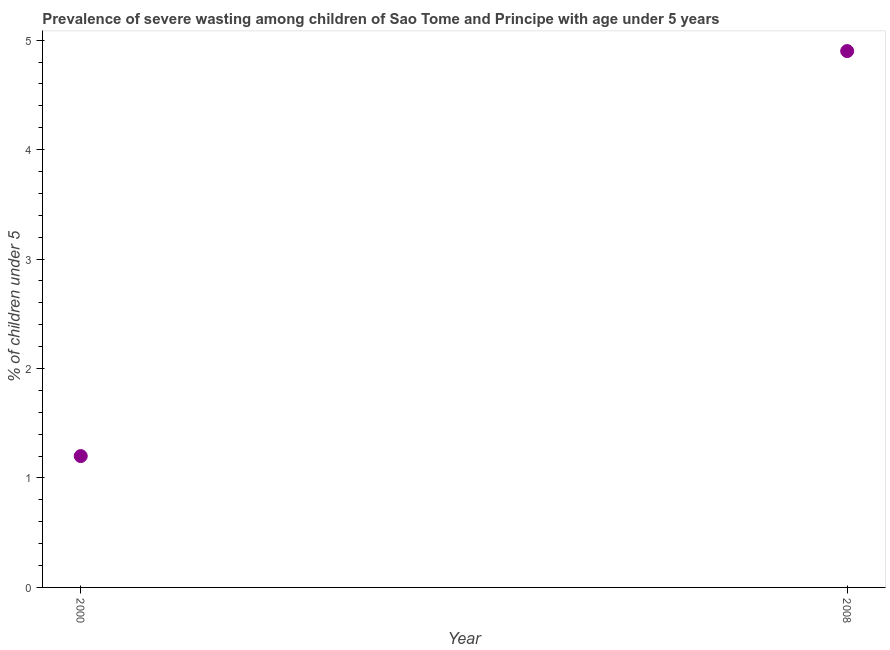What is the prevalence of severe wasting in 2000?
Your answer should be very brief. 1.2. Across all years, what is the maximum prevalence of severe wasting?
Ensure brevity in your answer.  4.9. Across all years, what is the minimum prevalence of severe wasting?
Your response must be concise. 1.2. In which year was the prevalence of severe wasting maximum?
Give a very brief answer. 2008. What is the sum of the prevalence of severe wasting?
Offer a terse response. 6.1. What is the difference between the prevalence of severe wasting in 2000 and 2008?
Provide a succinct answer. -3.7. What is the average prevalence of severe wasting per year?
Your answer should be compact. 3.05. What is the median prevalence of severe wasting?
Offer a terse response. 3.05. What is the ratio of the prevalence of severe wasting in 2000 to that in 2008?
Provide a short and direct response. 0.24. In how many years, is the prevalence of severe wasting greater than the average prevalence of severe wasting taken over all years?
Offer a terse response. 1. Does the prevalence of severe wasting monotonically increase over the years?
Provide a succinct answer. Yes. What is the difference between two consecutive major ticks on the Y-axis?
Your answer should be very brief. 1. Are the values on the major ticks of Y-axis written in scientific E-notation?
Ensure brevity in your answer.  No. What is the title of the graph?
Provide a short and direct response. Prevalence of severe wasting among children of Sao Tome and Principe with age under 5 years. What is the label or title of the Y-axis?
Your answer should be compact.  % of children under 5. What is the  % of children under 5 in 2000?
Keep it short and to the point. 1.2. What is the  % of children under 5 in 2008?
Offer a very short reply. 4.9. What is the ratio of the  % of children under 5 in 2000 to that in 2008?
Offer a very short reply. 0.24. 